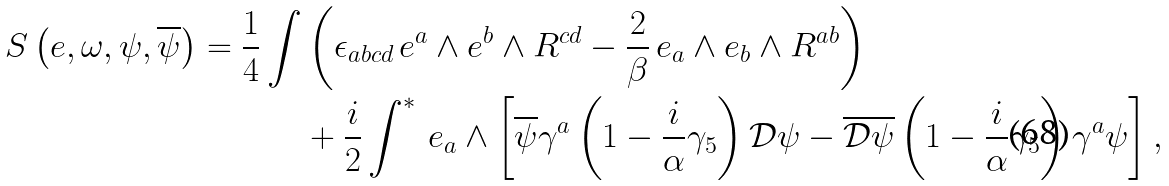<formula> <loc_0><loc_0><loc_500><loc_500>S \left ( e , \omega , \psi , \overline { \psi } \right ) = \frac { 1 } { 4 } \int & \left ( \epsilon _ { a b c d } \, e ^ { a } \wedge e ^ { b } \wedge R ^ { c d } - \frac { 2 } { \beta } \, e _ { a } \wedge e _ { b } \wedge R ^ { a b } \right ) \\ & + \frac { i } { 2 } \int ^ { * } \, e _ { a } \wedge \left [ \overline { \psi } \gamma ^ { a } \left ( 1 - \frac { i } { \alpha } \gamma _ { 5 } \right ) \mathcal { D } \psi - \overline { \mathcal { D } \psi } \left ( 1 - \frac { i } { \alpha } \gamma _ { 5 } \right ) \gamma ^ { a } \psi \right ] ,</formula> 